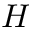<formula> <loc_0><loc_0><loc_500><loc_500>H</formula> 